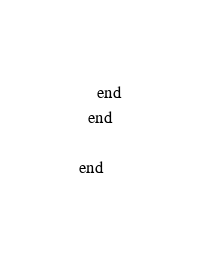<code> <loc_0><loc_0><loc_500><loc_500><_Ruby_>    end
  end

end
</code> 